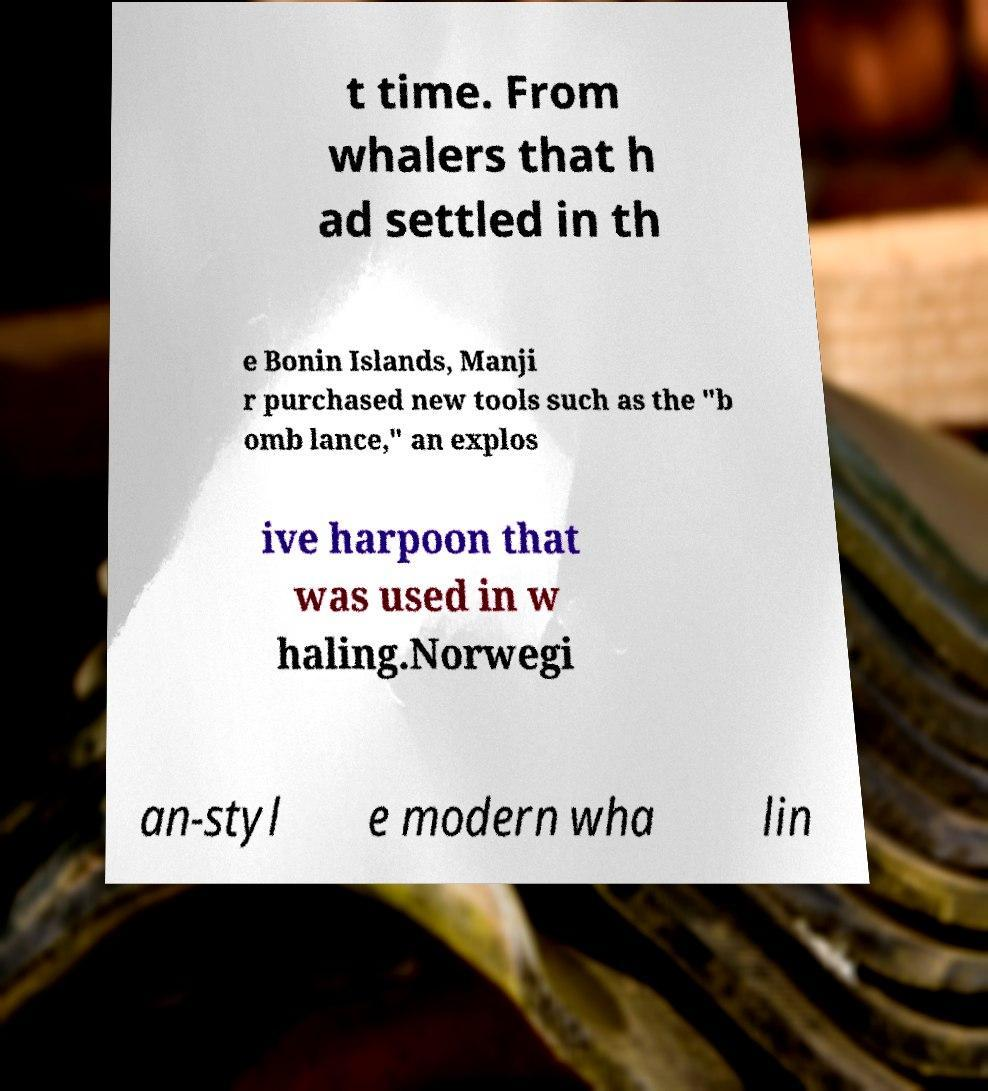Please identify and transcribe the text found in this image. t time. From whalers that h ad settled in th e Bonin Islands, Manji r purchased new tools such as the "b omb lance," an explos ive harpoon that was used in w haling.Norwegi an-styl e modern wha lin 